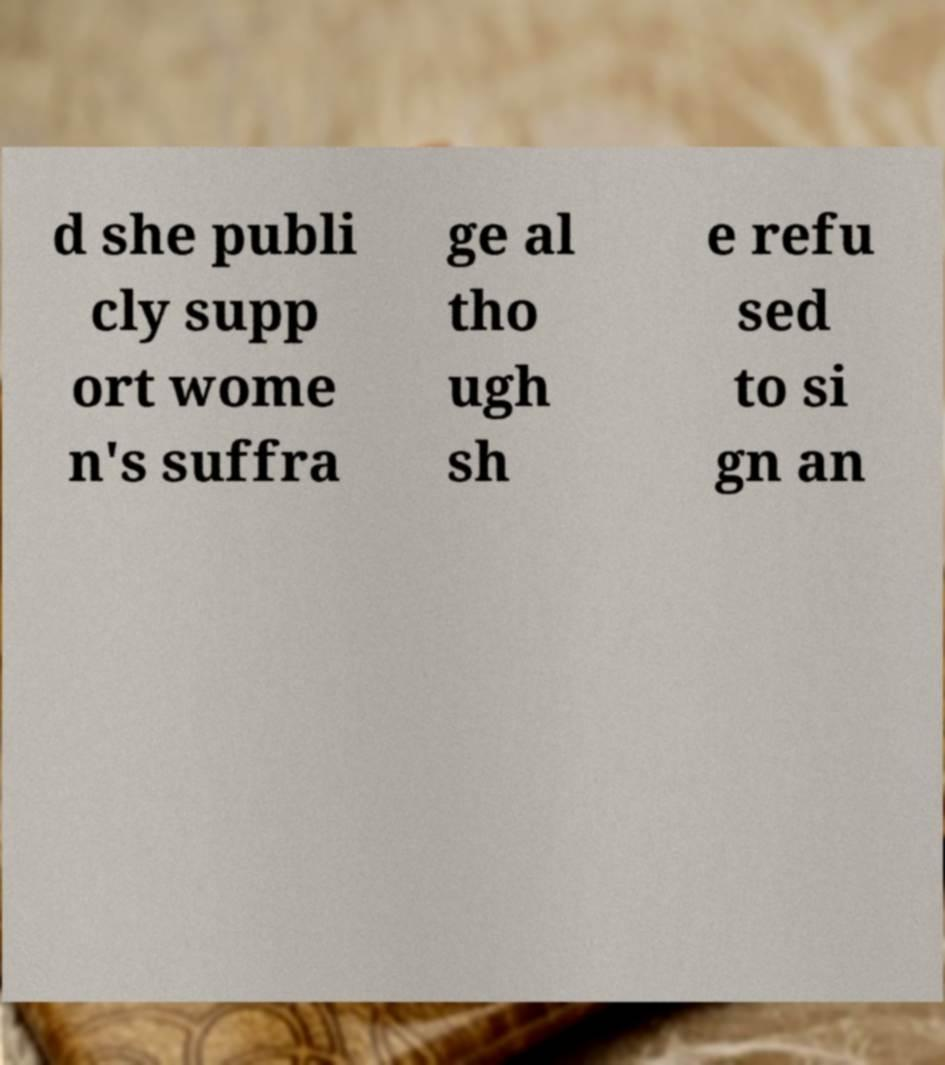I need the written content from this picture converted into text. Can you do that? d she publi cly supp ort wome n's suffra ge al tho ugh sh e refu sed to si gn an 